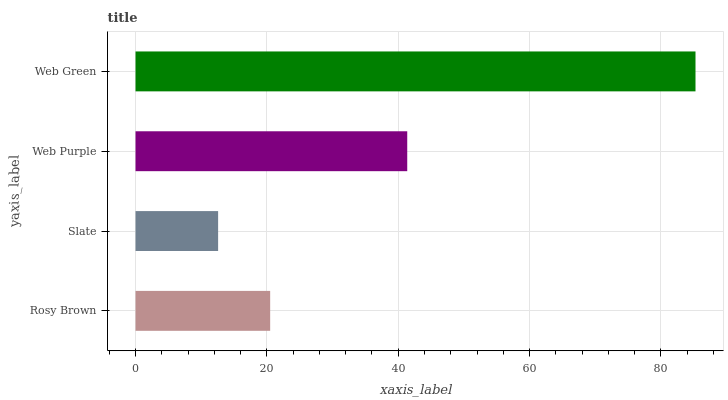Is Slate the minimum?
Answer yes or no. Yes. Is Web Green the maximum?
Answer yes or no. Yes. Is Web Purple the minimum?
Answer yes or no. No. Is Web Purple the maximum?
Answer yes or no. No. Is Web Purple greater than Slate?
Answer yes or no. Yes. Is Slate less than Web Purple?
Answer yes or no. Yes. Is Slate greater than Web Purple?
Answer yes or no. No. Is Web Purple less than Slate?
Answer yes or no. No. Is Web Purple the high median?
Answer yes or no. Yes. Is Rosy Brown the low median?
Answer yes or no. Yes. Is Slate the high median?
Answer yes or no. No. Is Web Green the low median?
Answer yes or no. No. 